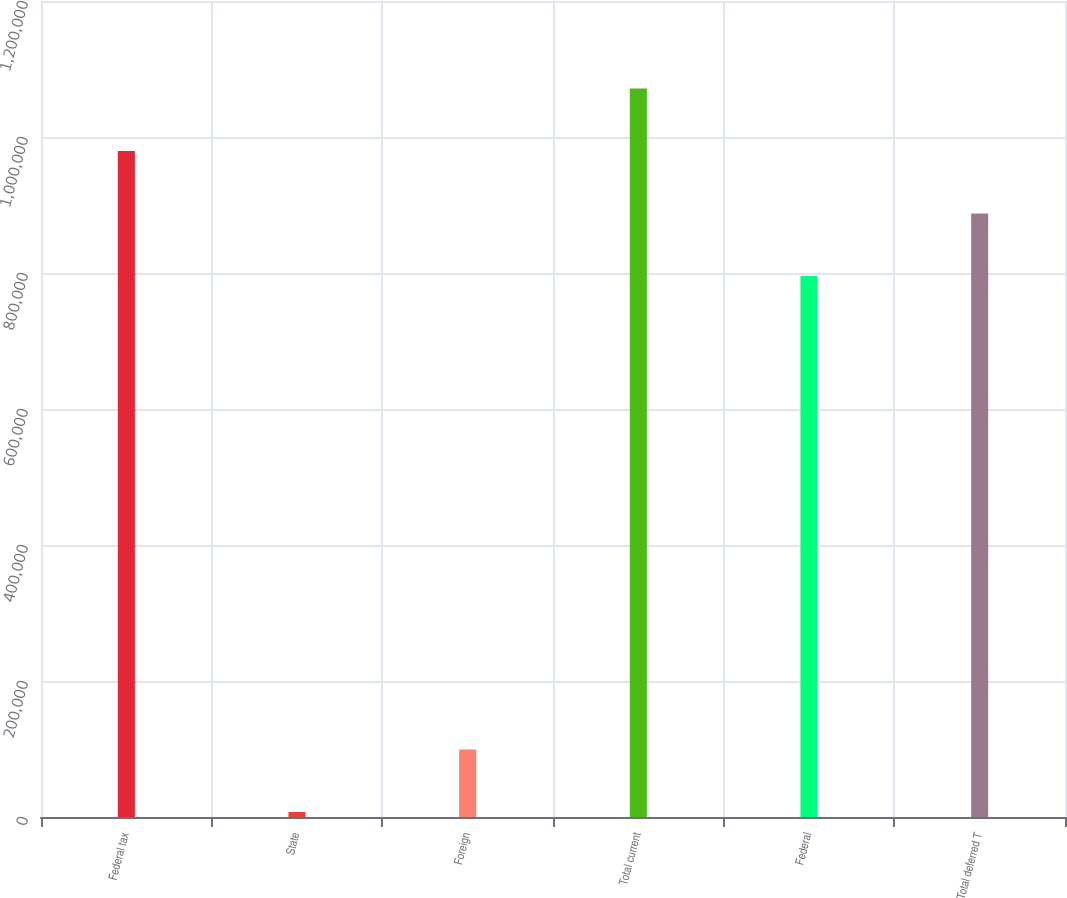Convert chart to OTSL. <chart><loc_0><loc_0><loc_500><loc_500><bar_chart><fcel>Federal tax<fcel>State<fcel>Foreign<fcel>Total current<fcel>Federal<fcel>Total deferred T<nl><fcel>979430<fcel>7335<fcel>99311<fcel>1.07141e+06<fcel>795478<fcel>887454<nl></chart> 